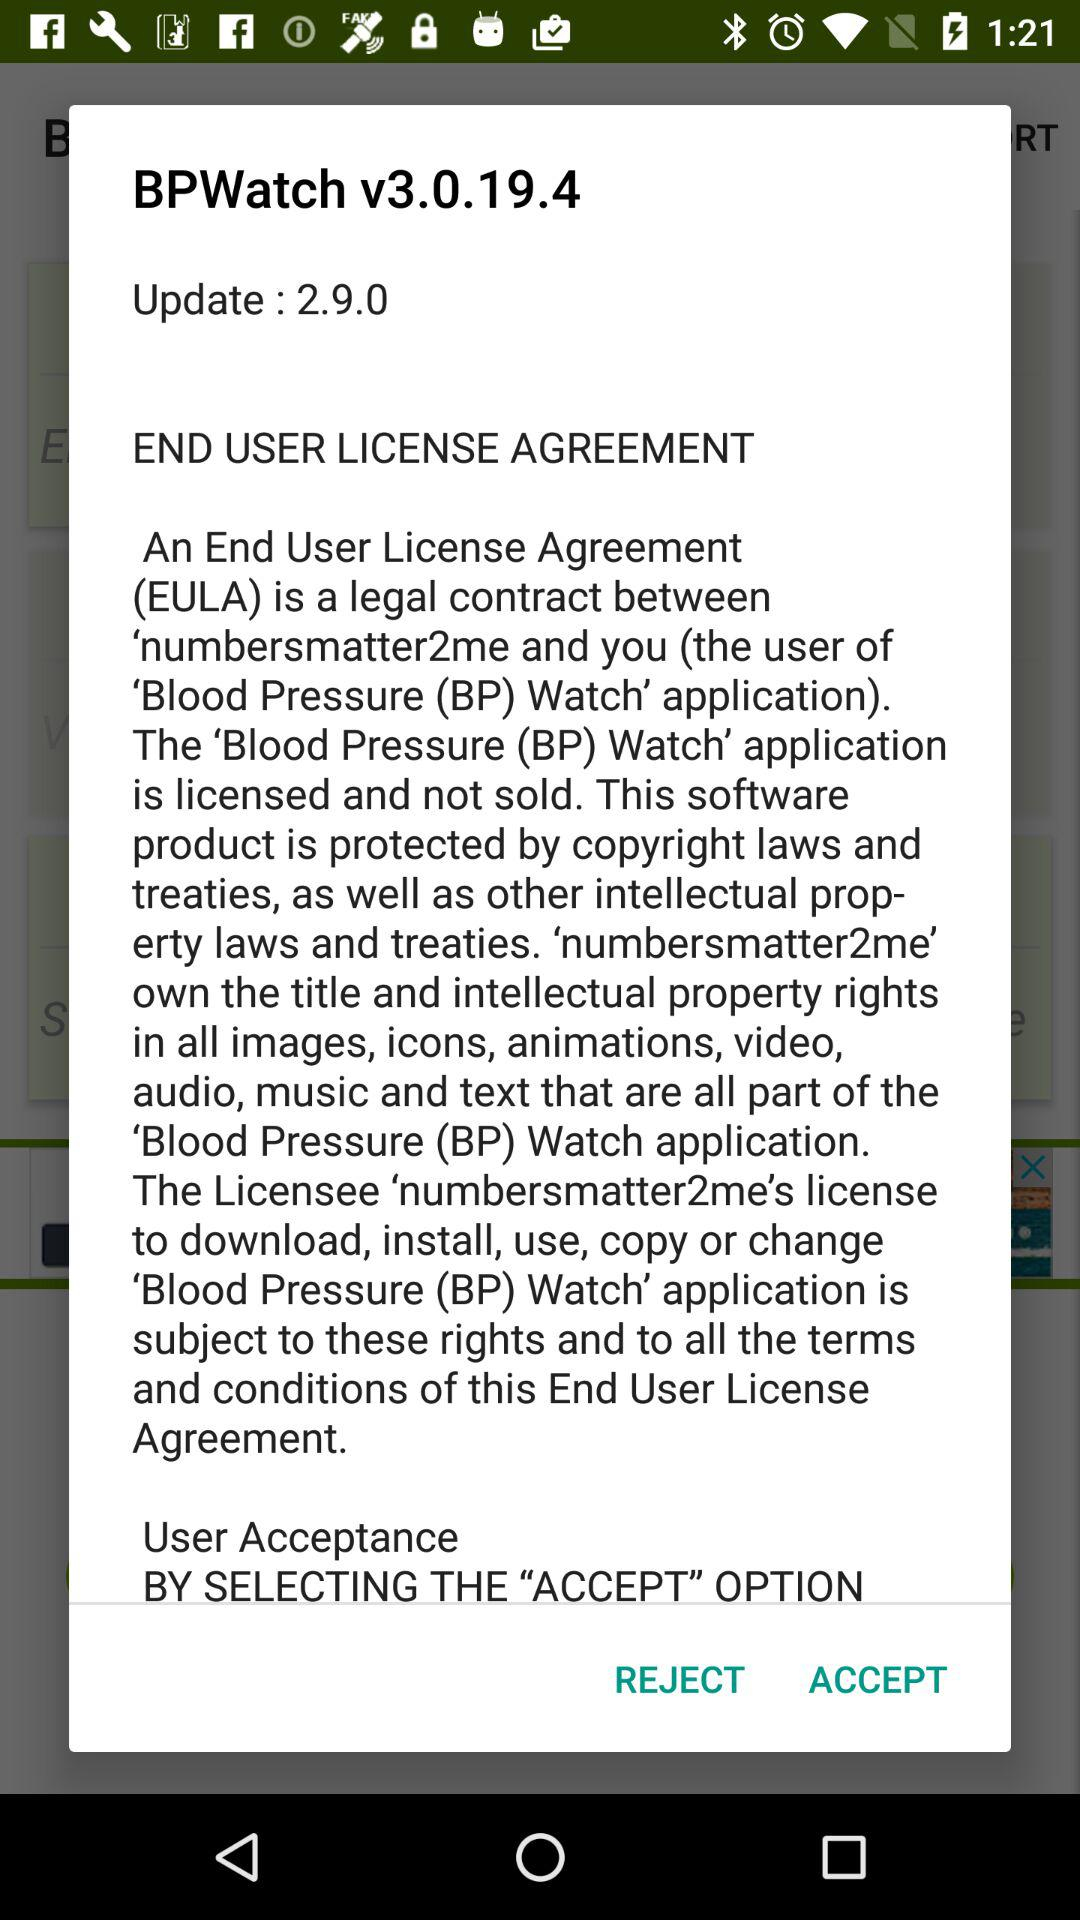What is an End User License Agreement? An End User License Agreement (EULA) is a legal contract between "numbersmatter2me" and you (the user of the "Blood Pressure (BP) Watch" application). 